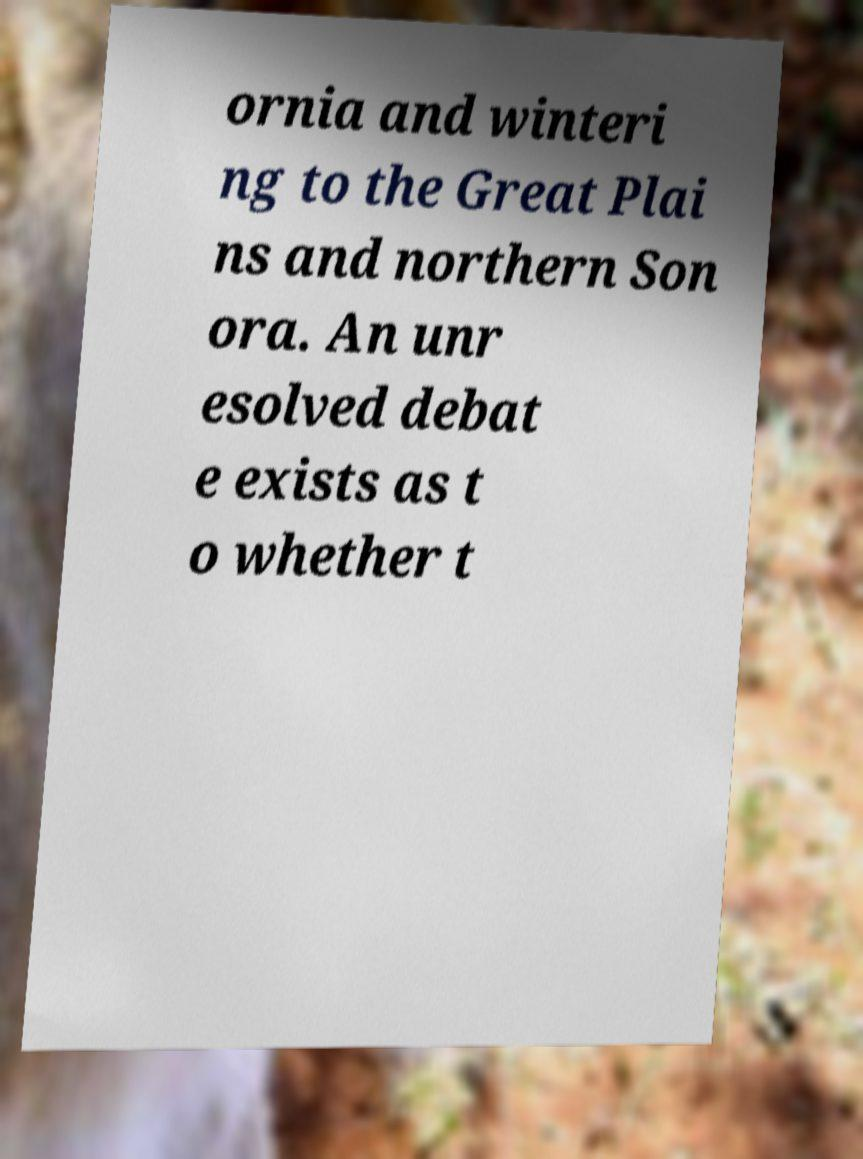Could you extract and type out the text from this image? ornia and winteri ng to the Great Plai ns and northern Son ora. An unr esolved debat e exists as t o whether t 